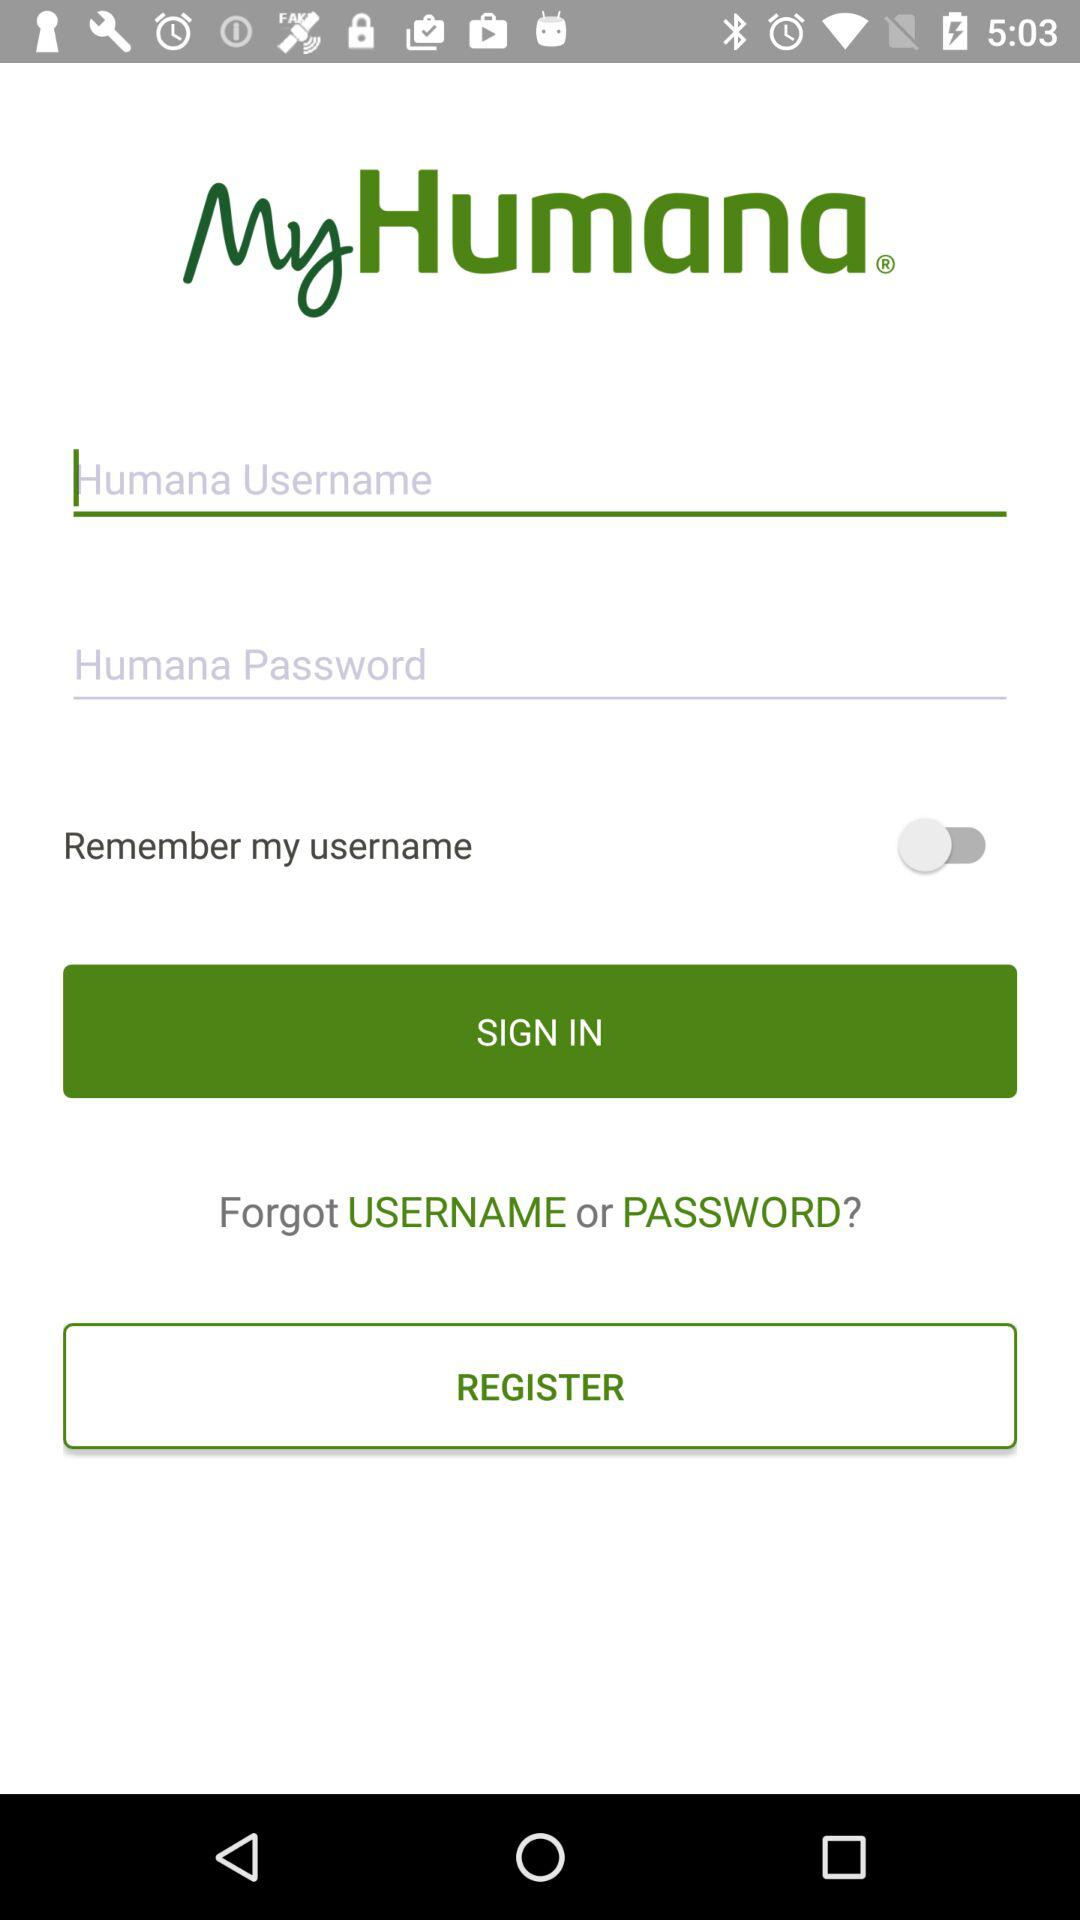What is the application name? The application name is "MyHumana". 